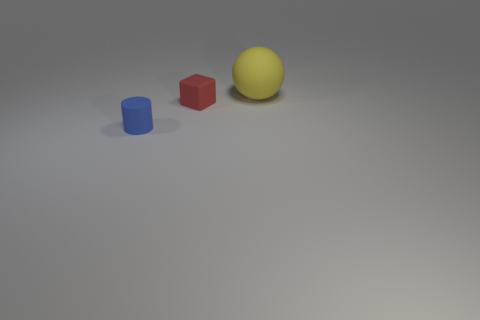There is a tiny red object; how many matte objects are behind it?
Make the answer very short. 1. What number of blue matte objects are there?
Provide a succinct answer. 1. Do the yellow matte sphere and the rubber block have the same size?
Ensure brevity in your answer.  No. Are there any large rubber things in front of the rubber object that is on the left side of the small rubber thing that is behind the blue thing?
Offer a very short reply. No. What color is the matte thing right of the red cube?
Ensure brevity in your answer.  Yellow. The red object has what size?
Your answer should be compact. Small. There is a matte ball; does it have the same size as the rubber thing that is left of the tiny red matte cube?
Your answer should be compact. No. What is the color of the small object to the left of the small thing that is behind the matte object on the left side of the block?
Your answer should be very brief. Blue. Is the material of the tiny thing that is to the right of the tiny blue rubber cylinder the same as the blue object?
Give a very brief answer. Yes. How many other things are made of the same material as the big yellow sphere?
Your response must be concise. 2. 